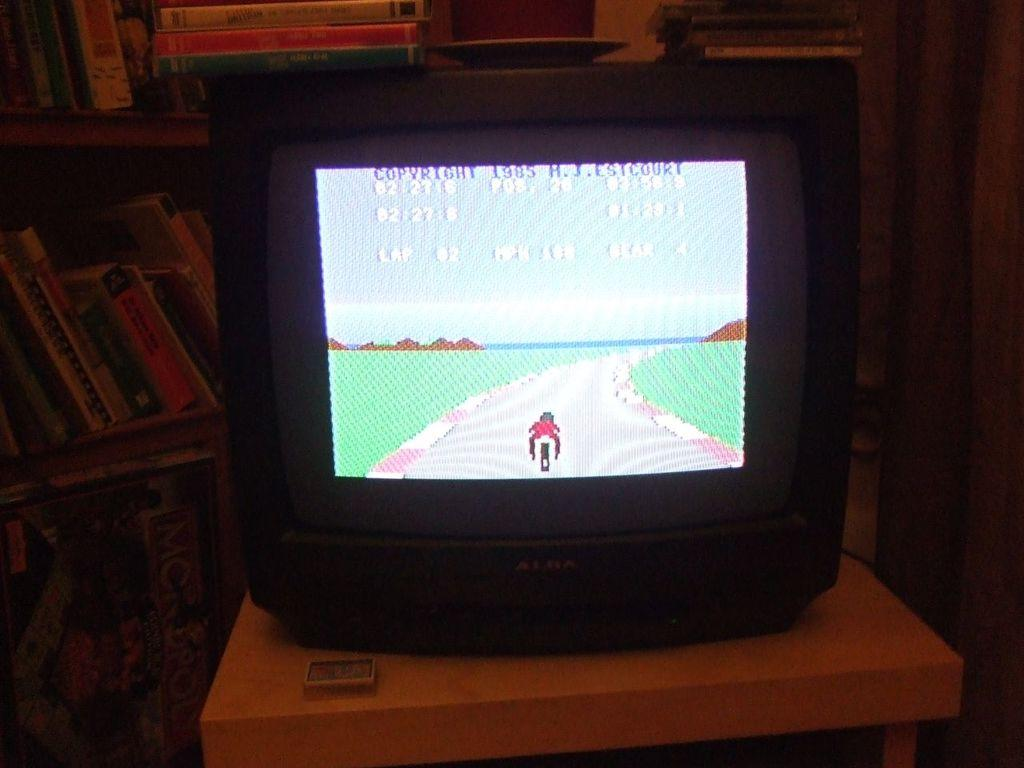<image>
Summarize the visual content of the image. The old school game has a copyright from 1985. 